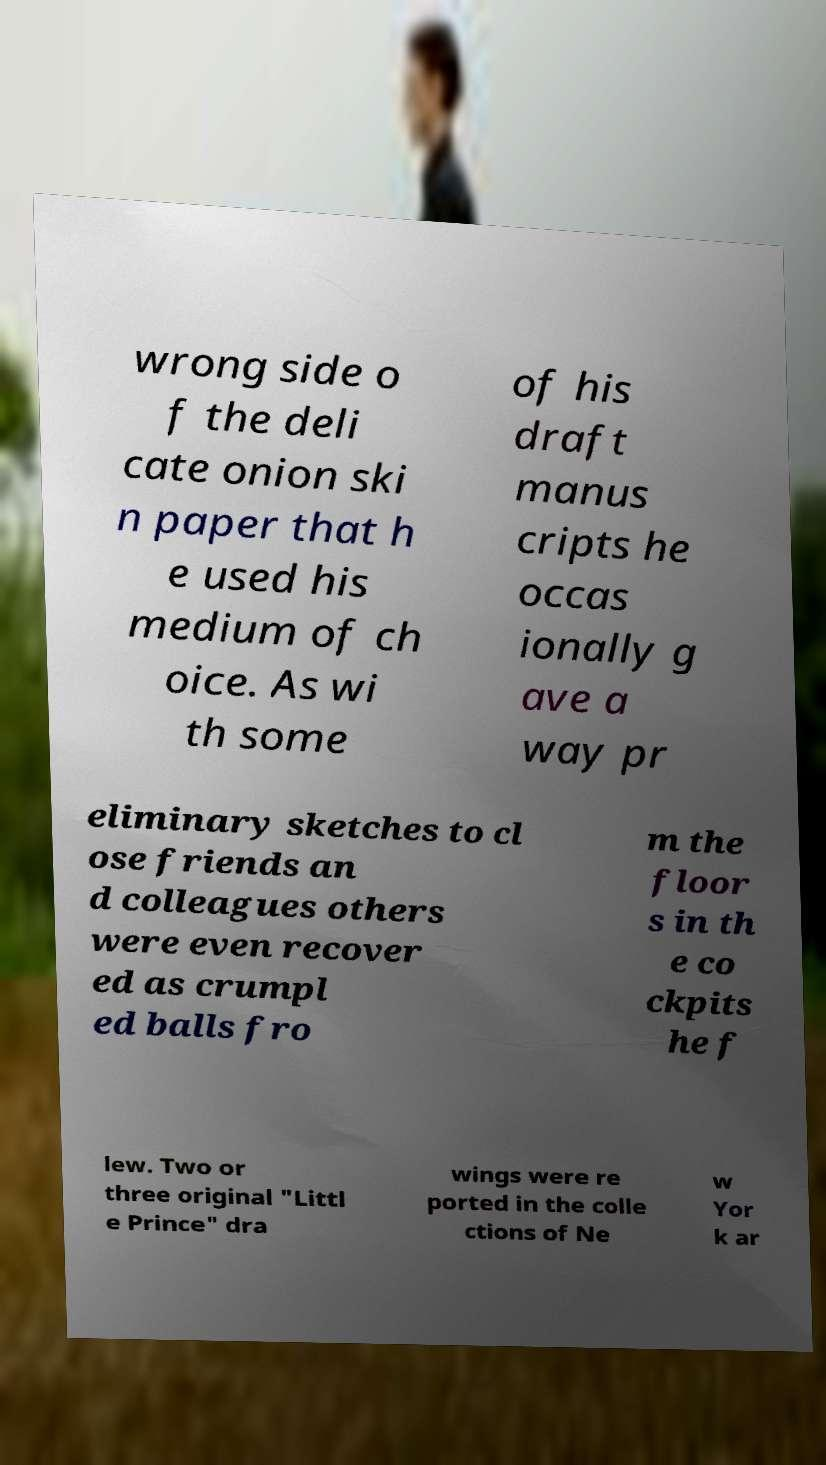I need the written content from this picture converted into text. Can you do that? wrong side o f the deli cate onion ski n paper that h e used his medium of ch oice. As wi th some of his draft manus cripts he occas ionally g ave a way pr eliminary sketches to cl ose friends an d colleagues others were even recover ed as crumpl ed balls fro m the floor s in th e co ckpits he f lew. Two or three original "Littl e Prince" dra wings were re ported in the colle ctions of Ne w Yor k ar 